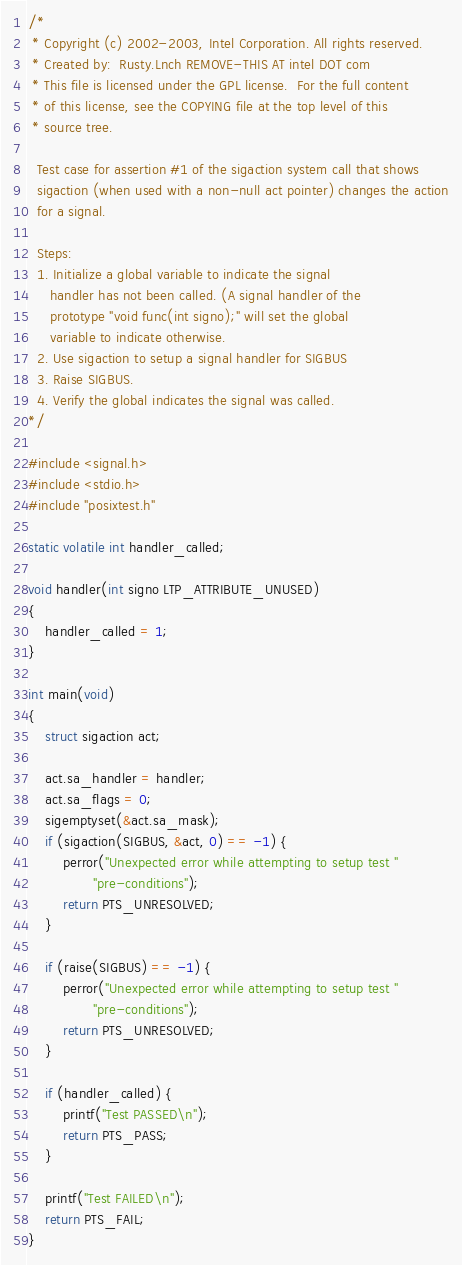<code> <loc_0><loc_0><loc_500><loc_500><_C_>/*
 * Copyright (c) 2002-2003, Intel Corporation. All rights reserved.
 * Created by:  Rusty.Lnch REMOVE-THIS AT intel DOT com
 * This file is licensed under the GPL license.  For the full content
 * of this license, see the COPYING file at the top level of this
 * source tree.

  Test case for assertion #1 of the sigaction system call that shows
  sigaction (when used with a non-null act pointer) changes the action
  for a signal.

  Steps:
  1. Initialize a global variable to indicate the signal
     handler has not been called. (A signal handler of the
     prototype "void func(int signo);" will set the global
     variable to indicate otherwise.
  2. Use sigaction to setup a signal handler for SIGBUS
  3. Raise SIGBUS.
  4. Verify the global indicates the signal was called.
*/

#include <signal.h>
#include <stdio.h>
#include "posixtest.h"

static volatile int handler_called;

void handler(int signo LTP_ATTRIBUTE_UNUSED)
{
	handler_called = 1;
}

int main(void)
{
	struct sigaction act;

	act.sa_handler = handler;
	act.sa_flags = 0;
	sigemptyset(&act.sa_mask);
	if (sigaction(SIGBUS, &act, 0) == -1) {
		perror("Unexpected error while attempting to setup test "
		       "pre-conditions");
		return PTS_UNRESOLVED;
	}

	if (raise(SIGBUS) == -1) {
		perror("Unexpected error while attempting to setup test "
		       "pre-conditions");
		return PTS_UNRESOLVED;
	}

	if (handler_called) {
		printf("Test PASSED\n");
		return PTS_PASS;
	}

	printf("Test FAILED\n");
	return PTS_FAIL;
}
</code> 